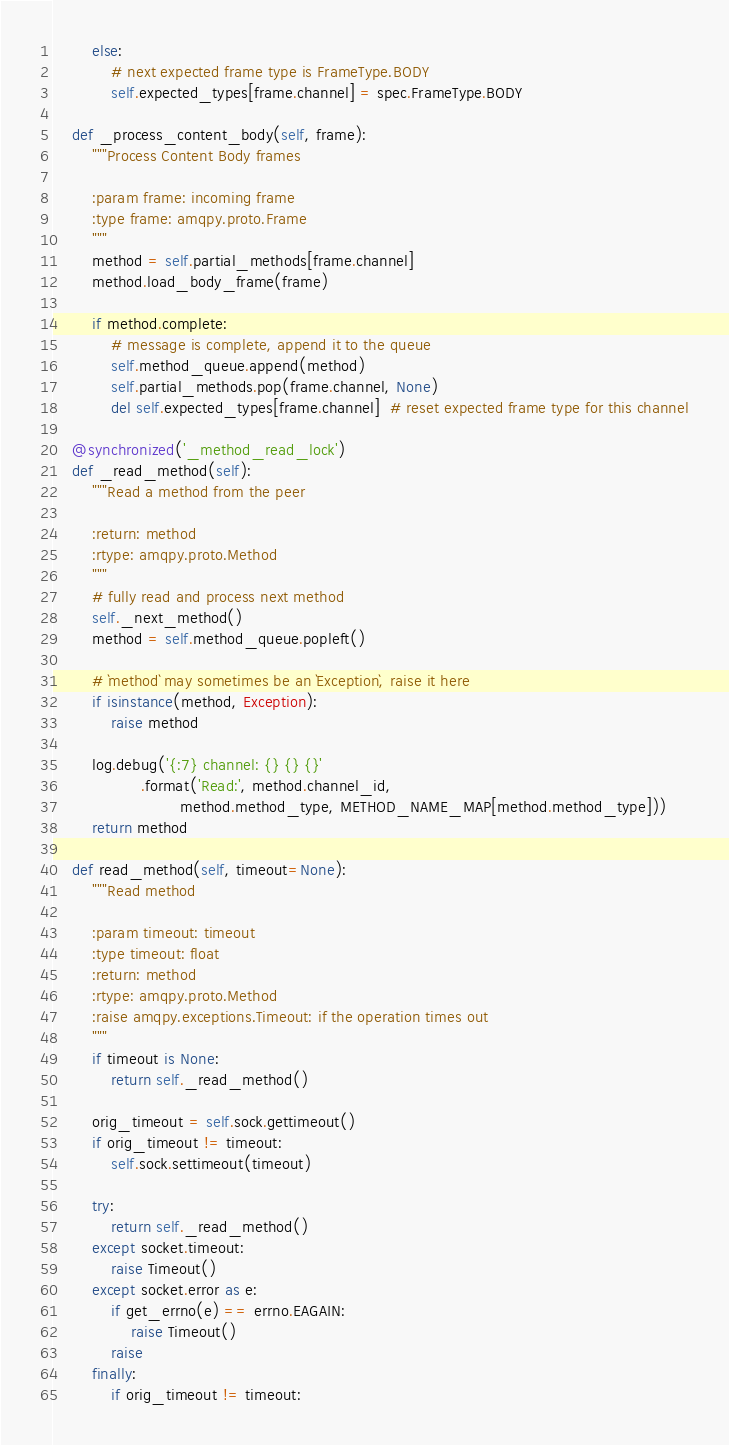Convert code to text. <code><loc_0><loc_0><loc_500><loc_500><_Python_>        else:
            # next expected frame type is FrameType.BODY
            self.expected_types[frame.channel] = spec.FrameType.BODY

    def _process_content_body(self, frame):
        """Process Content Body frames

        :param frame: incoming frame
        :type frame: amqpy.proto.Frame
        """
        method = self.partial_methods[frame.channel]
        method.load_body_frame(frame)

        if method.complete:
            # message is complete, append it to the queue
            self.method_queue.append(method)
            self.partial_methods.pop(frame.channel, None)
            del self.expected_types[frame.channel]  # reset expected frame type for this channel

    @synchronized('_method_read_lock')
    def _read_method(self):
        """Read a method from the peer

        :return: method
        :rtype: amqpy.proto.Method
        """
        # fully read and process next method
        self._next_method()
        method = self.method_queue.popleft()

        # `method` may sometimes be an `Exception`, raise it here
        if isinstance(method, Exception):
            raise method

        log.debug('{:7} channel: {} {} {}'
                  .format('Read:', method.channel_id,
                          method.method_type, METHOD_NAME_MAP[method.method_type]))
        return method

    def read_method(self, timeout=None):
        """Read method

        :param timeout: timeout
        :type timeout: float
        :return: method
        :rtype: amqpy.proto.Method
        :raise amqpy.exceptions.Timeout: if the operation times out
        """
        if timeout is None:
            return self._read_method()

        orig_timeout = self.sock.gettimeout()
        if orig_timeout != timeout:
            self.sock.settimeout(timeout)

        try:
            return self._read_method()
        except socket.timeout:
            raise Timeout()
        except socket.error as e:
            if get_errno(e) == errno.EAGAIN:
                raise Timeout()
            raise
        finally:
            if orig_timeout != timeout:</code> 